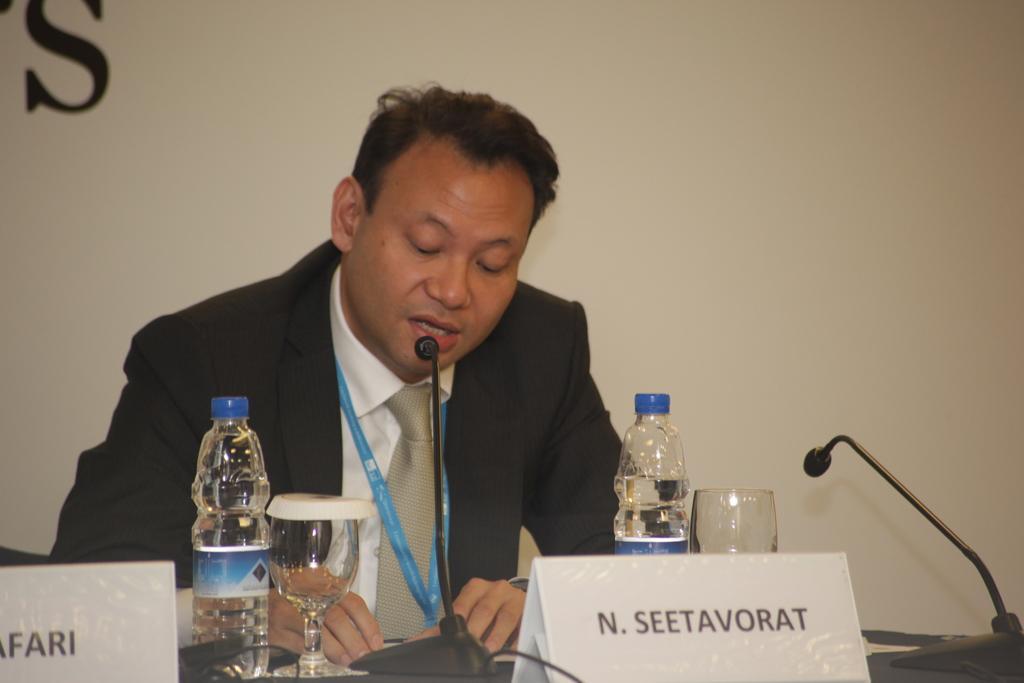Could you give a brief overview of what you see in this image? In this image there is a man sitting , there are bottles, mike's, glasses, name plates on the table, and in the background there is a wall. 